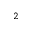Convert formula to latex. <formula><loc_0><loc_0><loc_500><loc_500>_ { 2 }</formula> 